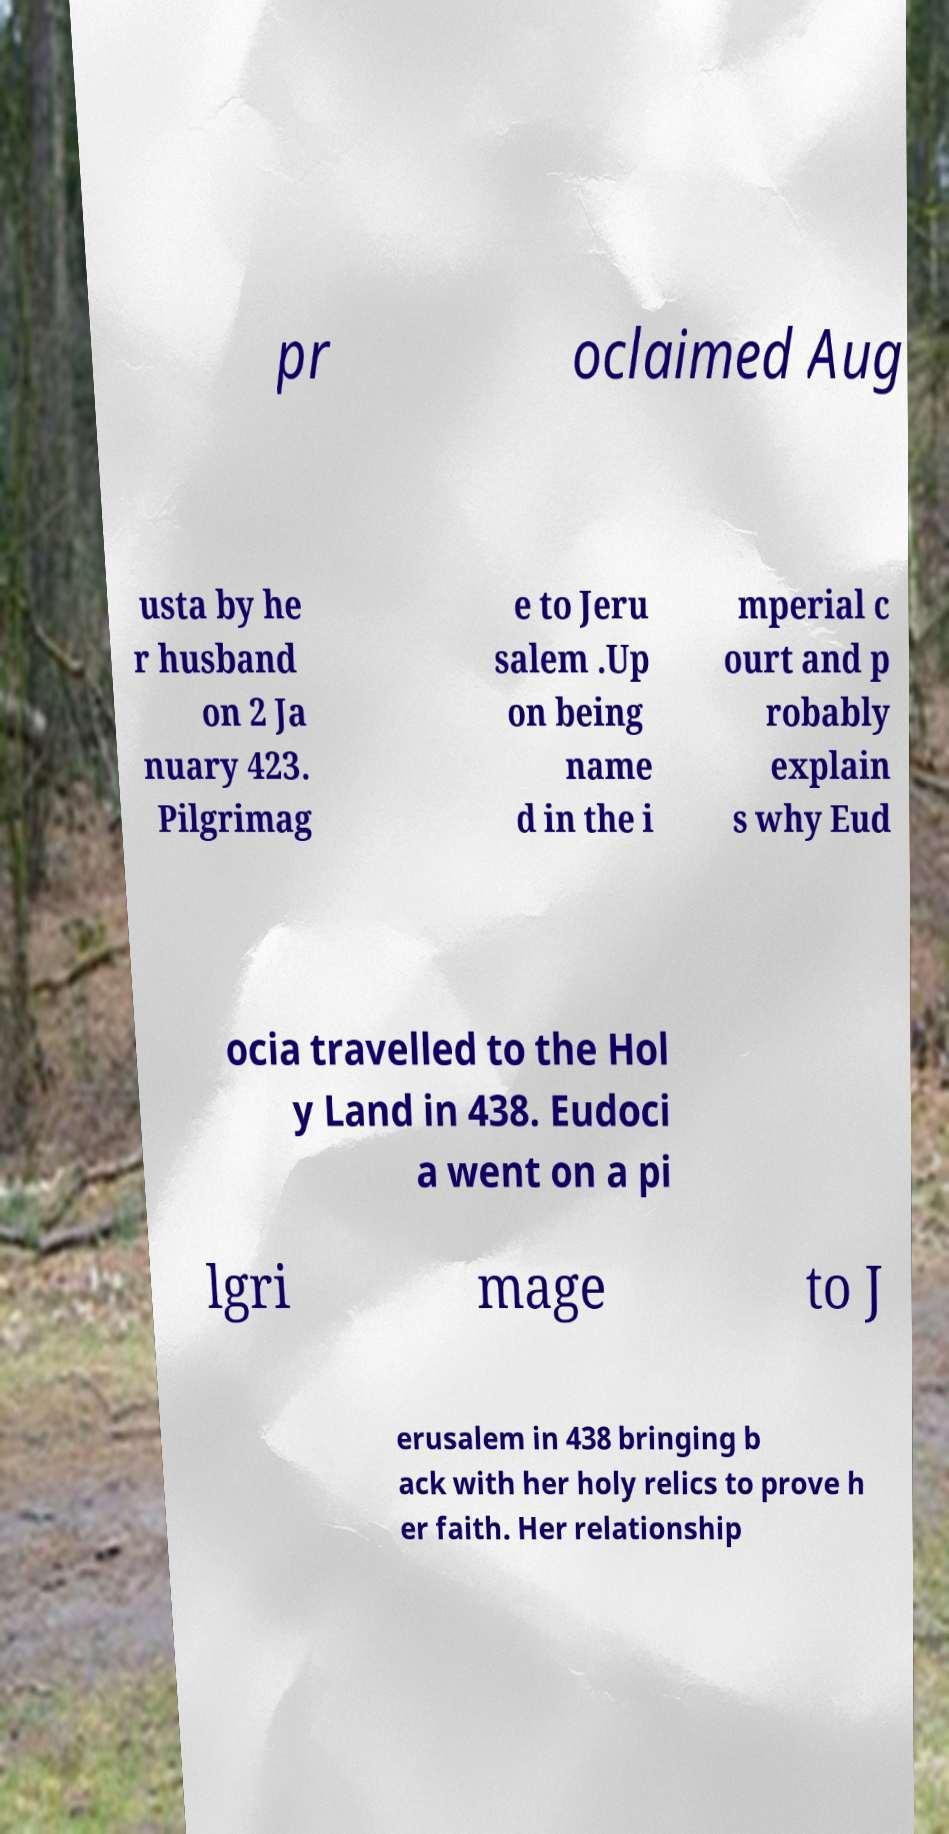I need the written content from this picture converted into text. Can you do that? pr oclaimed Aug usta by he r husband on 2 Ja nuary 423. Pilgrimag e to Jeru salem .Up on being name d in the i mperial c ourt and p robably explain s why Eud ocia travelled to the Hol y Land in 438. Eudoci a went on a pi lgri mage to J erusalem in 438 bringing b ack with her holy relics to prove h er faith. Her relationship 